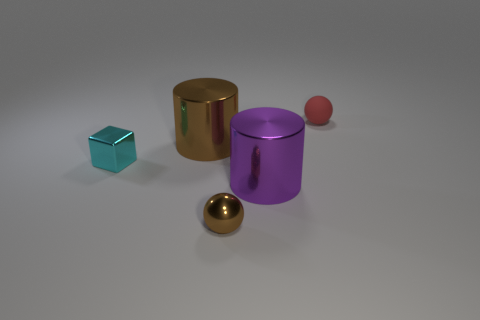What colors are the objects in the image, and which one is the largest? The objects in the image include a teal-colored cube, a gold cylinder, a purple cylinder, a red sphere, and a gold sphere. The gold cylinder appears to be the largest. Which objects look similar to each other? The gold and purple cylinders are similar in shape but differ in color, and the gold sphere and red sphere are both spherical but vary in size and color. 